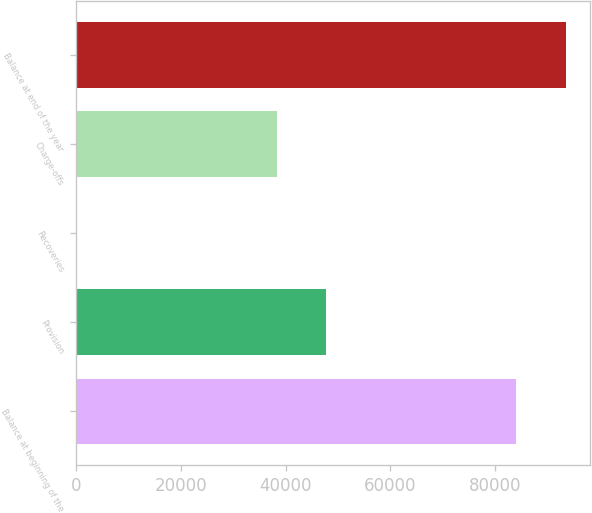Convert chart to OTSL. <chart><loc_0><loc_0><loc_500><loc_500><bar_chart><fcel>Balance at beginning of the<fcel>Provision<fcel>Recoveries<fcel>Charge-offs<fcel>Balance at end of the year<nl><fcel>84073<fcel>47750<fcel>88<fcel>38376<fcel>93535<nl></chart> 